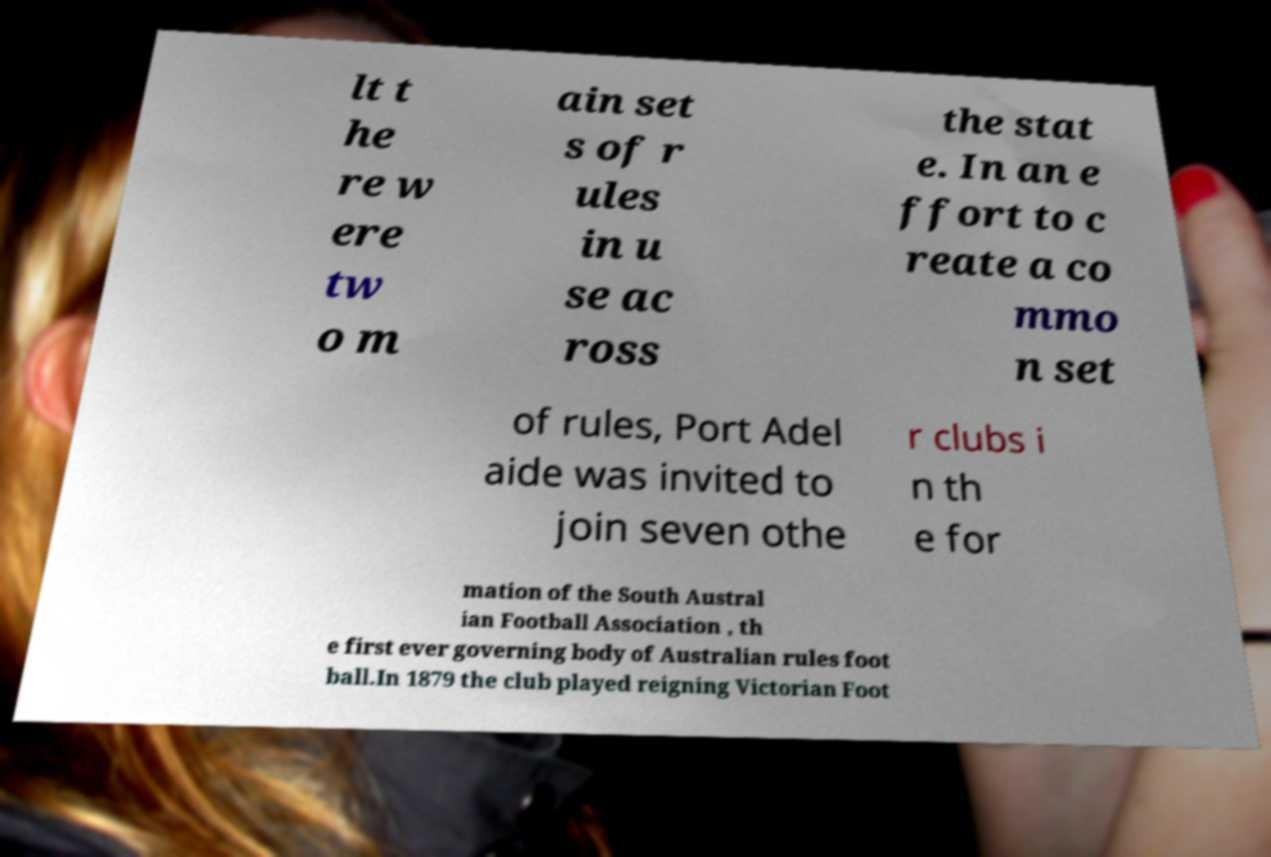Could you assist in decoding the text presented in this image and type it out clearly? lt t he re w ere tw o m ain set s of r ules in u se ac ross the stat e. In an e ffort to c reate a co mmo n set of rules, Port Adel aide was invited to join seven othe r clubs i n th e for mation of the South Austral ian Football Association , th e first ever governing body of Australian rules foot ball.In 1879 the club played reigning Victorian Foot 